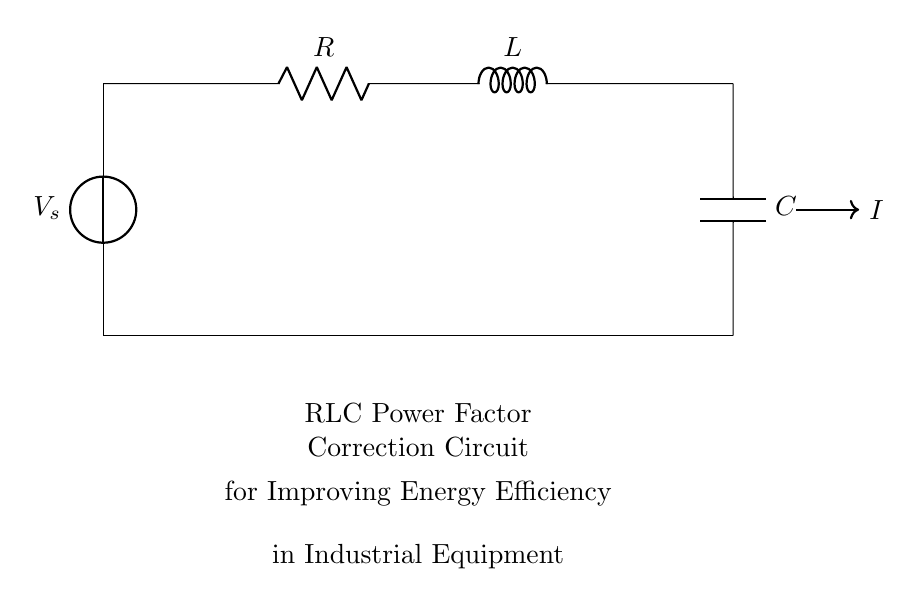What is the current flowing through the circuit? The current is denoted by the symbol "I" with an arrow indicating the direction of flow.
Answer: I What components are present in the circuit? The circuit consists of a voltage source (V), a resistor (R), an inductor (L), and a capacitor (C). These are standard components in an RLC circuit.
Answer: Voltage source, resistor, inductor, capacitor What direction does the current flow? The arrow pointing to the right next to "I" indicates that the current flows from left to right in the circuit.
Answer: Right What is the role of the capacitor in this circuit? The capacitor is used for power factor correction, helping to reduce the phase difference between current and voltage, thereby improving energy efficiency in industrial equipment.
Answer: Power factor correction How do RLC circuits improve energy efficiency? RLC circuits improve energy efficiency by correcting the power factor, reducing energy losses due to reactive power, and ensuring that the power is used effectively by industrial equipment.
Answer: By correcting power factor What is the relationship between the components in this circuit? In an RLC circuit, the resistor limits current, the inductor stores energy in a magnetic field, and the capacitor stores energy in an electric field, each contributing to the overall impedance and power factor of the system.
Answer: They interact to affect impedance and power factor 